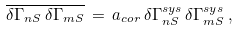Convert formula to latex. <formula><loc_0><loc_0><loc_500><loc_500>\overline { \delta \Gamma _ { n S } \, \delta \Gamma _ { m S } } \, = \, a _ { c o r } \, \delta \Gamma _ { n S } ^ { s y s } \, \delta \Gamma _ { m S } ^ { s y s } \, ,</formula> 